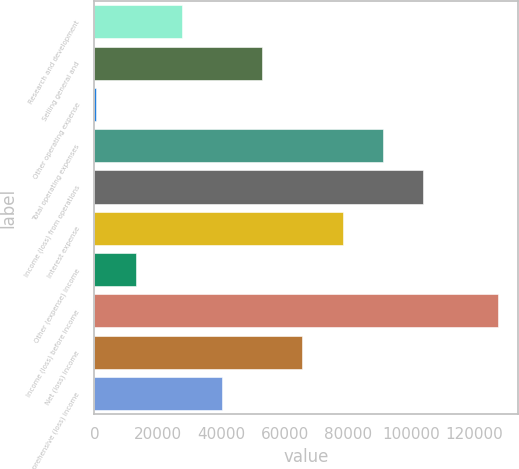Convert chart. <chart><loc_0><loc_0><loc_500><loc_500><bar_chart><fcel>Research and development<fcel>Selling general and<fcel>Other operating expense<fcel>Total operating expenses<fcel>Income (loss) from operations<fcel>Interest expense<fcel>Other (expense) income<fcel>Income (loss) before income<fcel>Net (loss) income<fcel>Comprehensive (loss) income<nl><fcel>27688<fcel>53014.4<fcel>588<fcel>91004<fcel>103667<fcel>78340.8<fcel>13251.2<fcel>127220<fcel>65677.6<fcel>40351.2<nl></chart> 